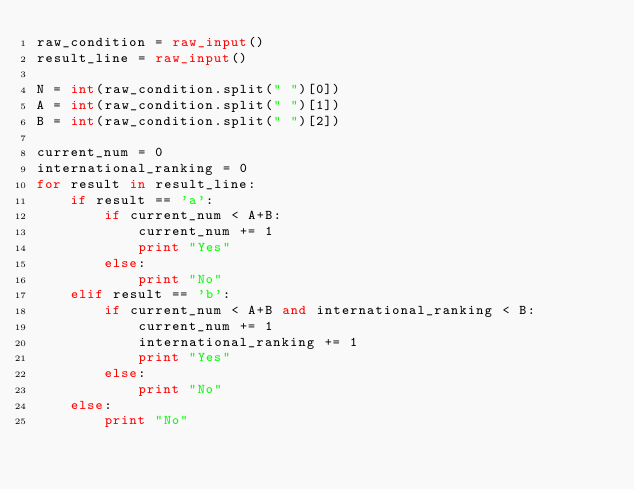Convert code to text. <code><loc_0><loc_0><loc_500><loc_500><_Python_>raw_condition = raw_input()
result_line = raw_input()

N = int(raw_condition.split(" ")[0])
A = int(raw_condition.split(" ")[1])
B = int(raw_condition.split(" ")[2])

current_num = 0
international_ranking = 0
for result in result_line:
    if result == 'a':
        if current_num < A+B:
            current_num += 1
            print "Yes"
        else:
            print "No"
    elif result == 'b':
        if current_num < A+B and international_ranking < B:
            current_num += 1
            international_ranking += 1
            print "Yes"
        else:
            print "No"
    else:
        print "No"</code> 